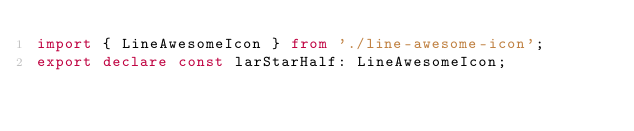Convert code to text. <code><loc_0><loc_0><loc_500><loc_500><_TypeScript_>import { LineAwesomeIcon } from './line-awesome-icon';
export declare const larStarHalf: LineAwesomeIcon;
</code> 